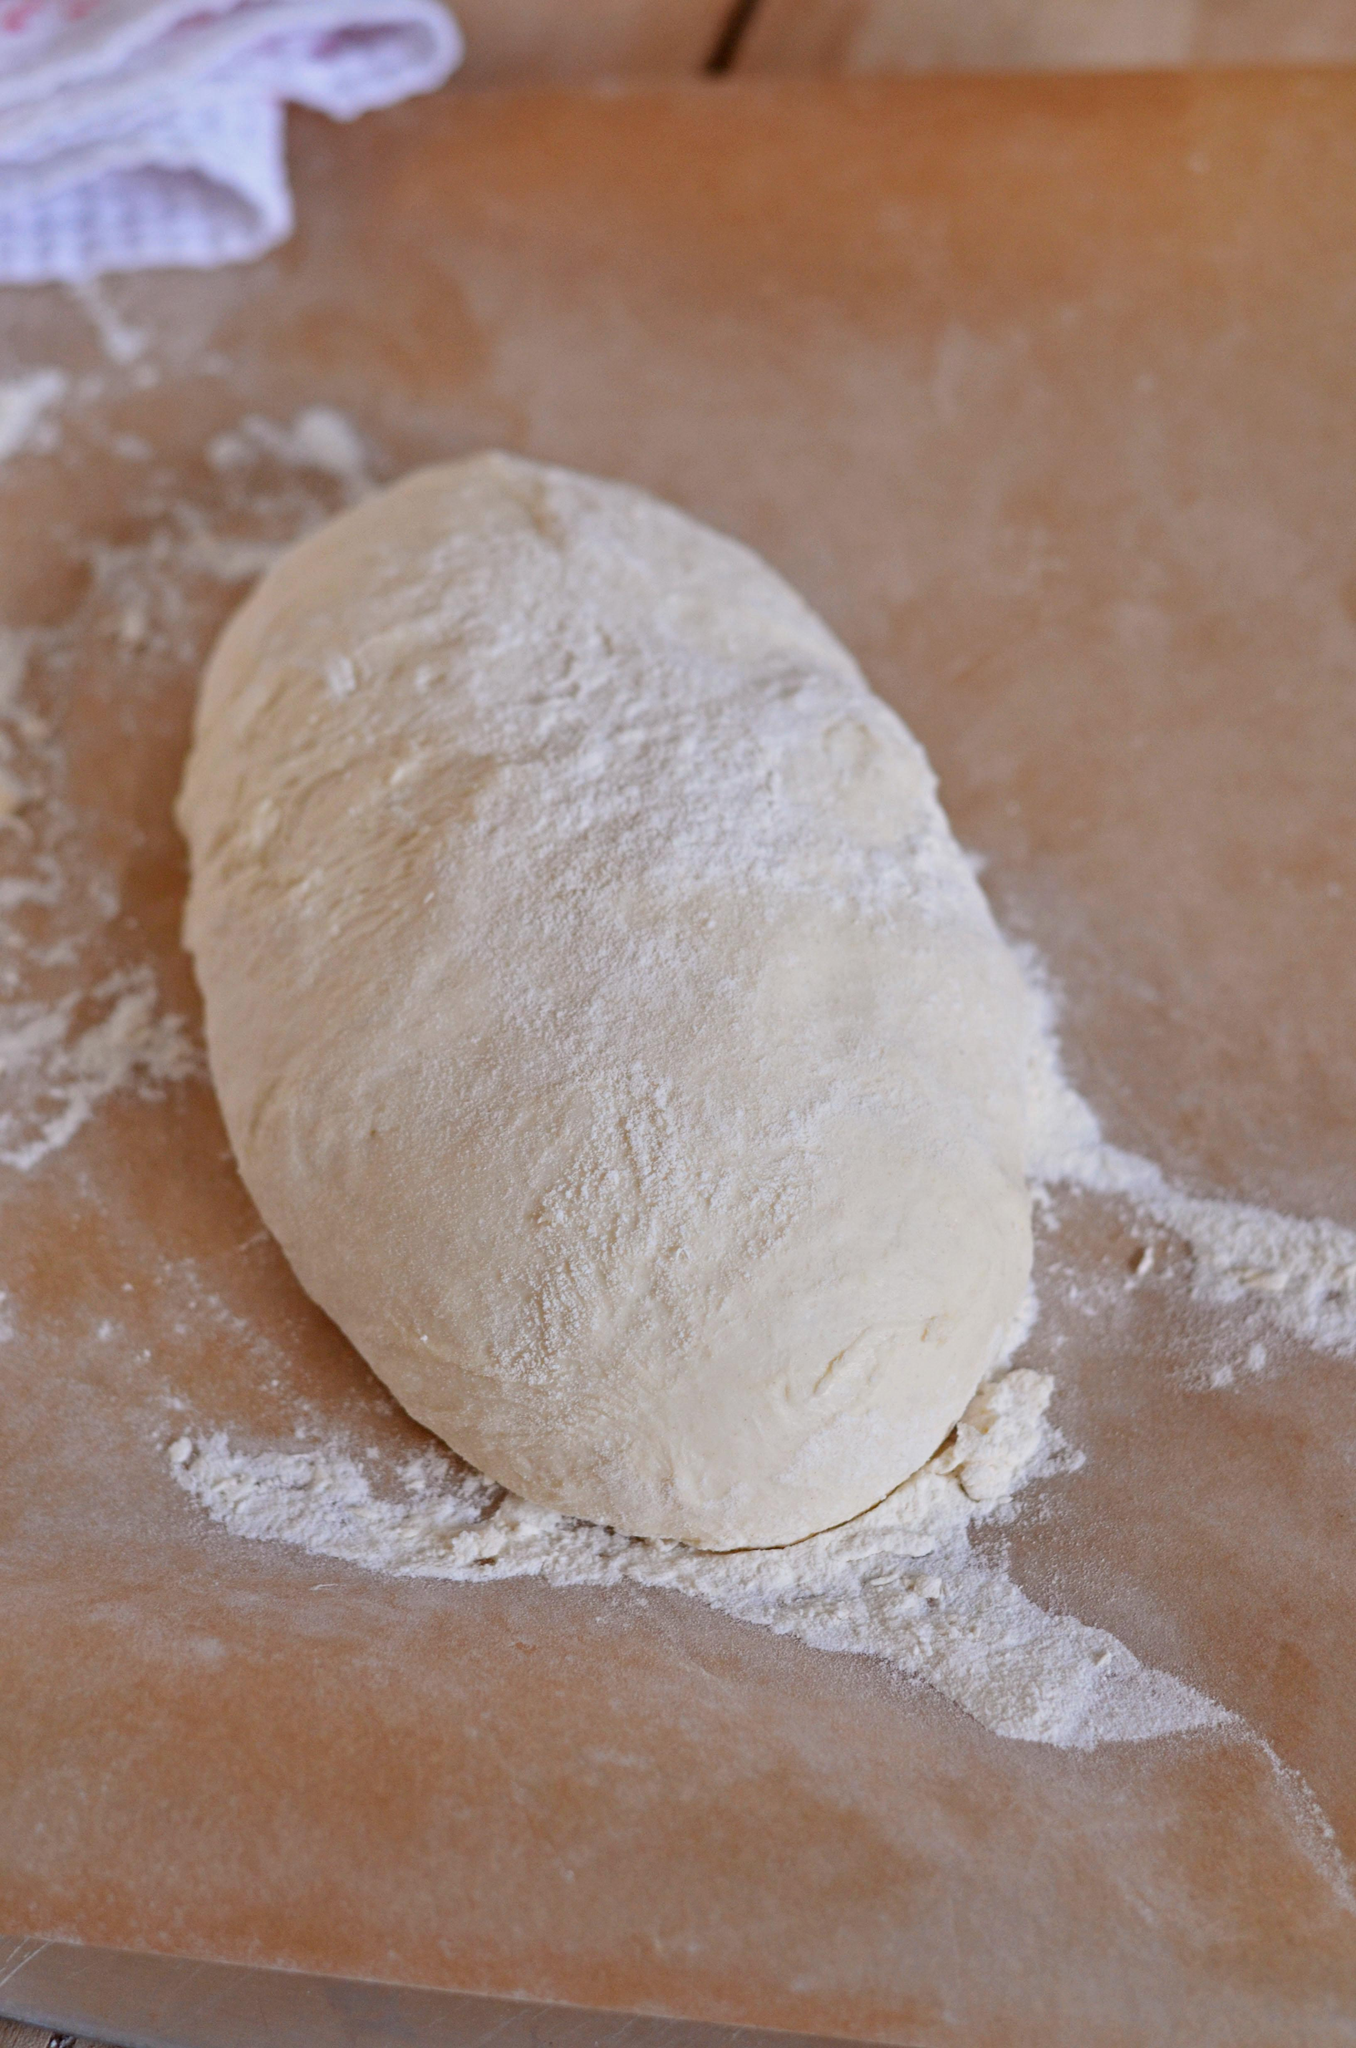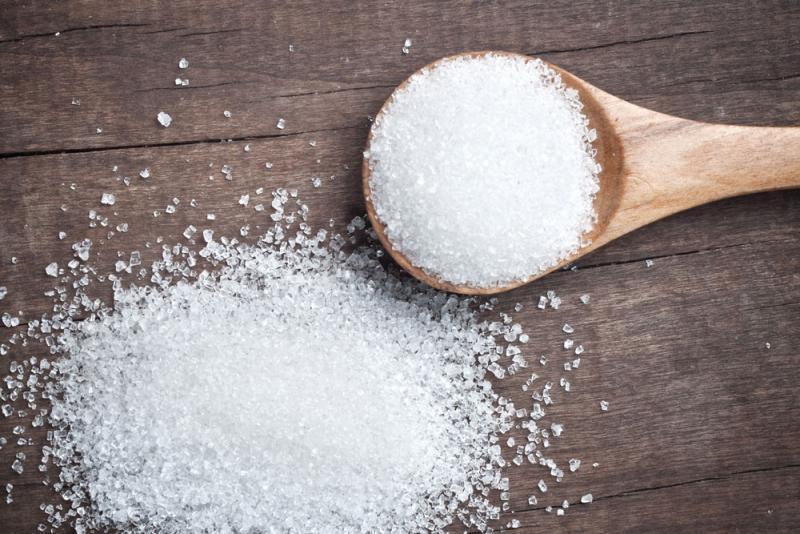The first image is the image on the left, the second image is the image on the right. Evaluate the accuracy of this statement regarding the images: "In one of the images, dough is being transferred out of a ceramic container.". Is it true? Answer yes or no. No. The first image is the image on the left, the second image is the image on the right. Given the left and right images, does the statement "The combined images show a mound of dough on a floured wooden counter and dough being dumped out of a loaf pan with ribbed texture." hold true? Answer yes or no. No. 